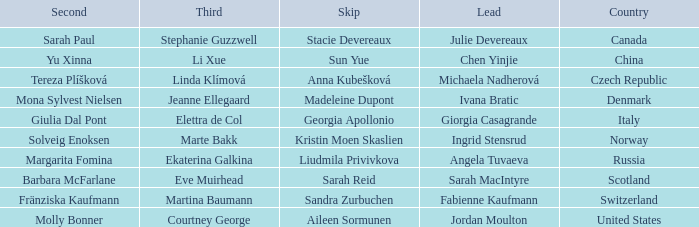What skip has angela tuvaeva as the lead? Liudmila Privivkova. 